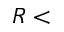Convert formula to latex. <formula><loc_0><loc_0><loc_500><loc_500>R <</formula> 